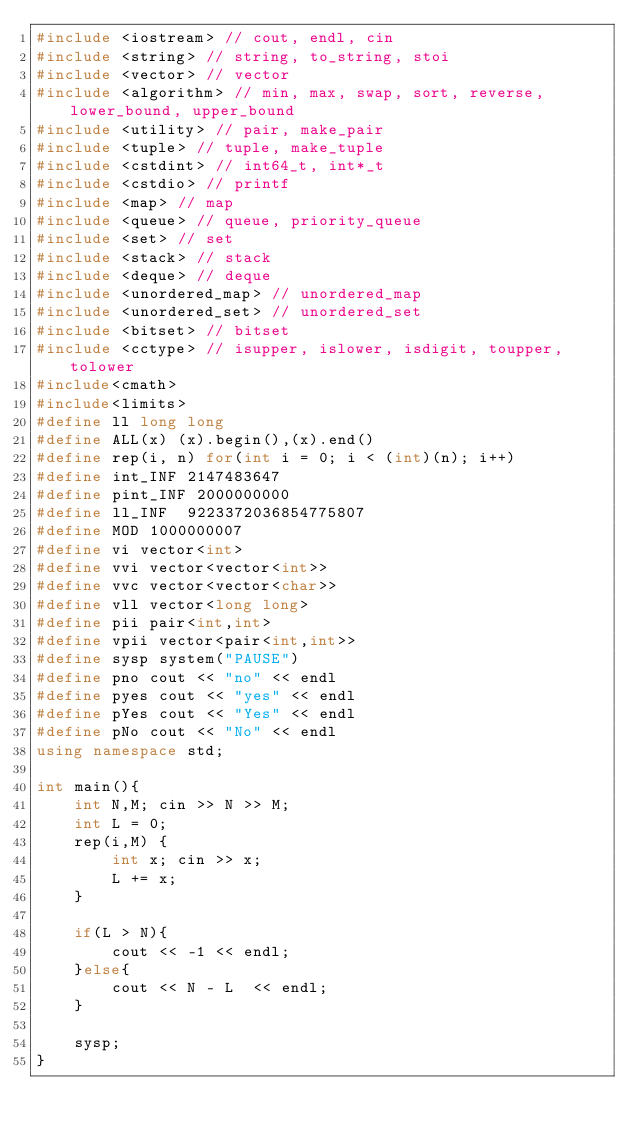<code> <loc_0><loc_0><loc_500><loc_500><_C++_>#include <iostream> // cout, endl, cin
#include <string> // string, to_string, stoi
#include <vector> // vector
#include <algorithm> // min, max, swap, sort, reverse, lower_bound, upper_bound
#include <utility> // pair, make_pair
#include <tuple> // tuple, make_tuple
#include <cstdint> // int64_t, int*_t
#include <cstdio> // printf
#include <map> // map
#include <queue> // queue, priority_queue
#include <set> // set
#include <stack> // stack
#include <deque> // deque
#include <unordered_map> // unordered_map
#include <unordered_set> // unordered_set
#include <bitset> // bitset
#include <cctype> // isupper, islower, isdigit, toupper, tolower
#include<cmath>
#include<limits>
#define ll long long
#define ALL(x) (x).begin(),(x).end()
#define rep(i, n) for(int i = 0; i < (int)(n); i++)
#define int_INF 2147483647
#define pint_INF 2000000000
#define ll_INF 	9223372036854775807
#define MOD 1000000007
#define vi vector<int>
#define vvi vector<vector<int>>
#define vvc vector<vector<char>>
#define vll vector<long long>
#define pii pair<int,int>
#define vpii vector<pair<int,int>>
#define sysp system("PAUSE")
#define pno cout << "no" << endl
#define pyes cout << "yes" << endl
#define pYes cout << "Yes" << endl
#define pNo cout << "No" << endl
using namespace std;

int main(){
    int N,M; cin >> N >> M;
    int L = 0;
    rep(i,M) {
        int x; cin >> x;
        L += x;
    }

    if(L > N){
        cout << -1 << endl;
    }else{
        cout << N - L  << endl;
    }

    sysp;
}</code> 